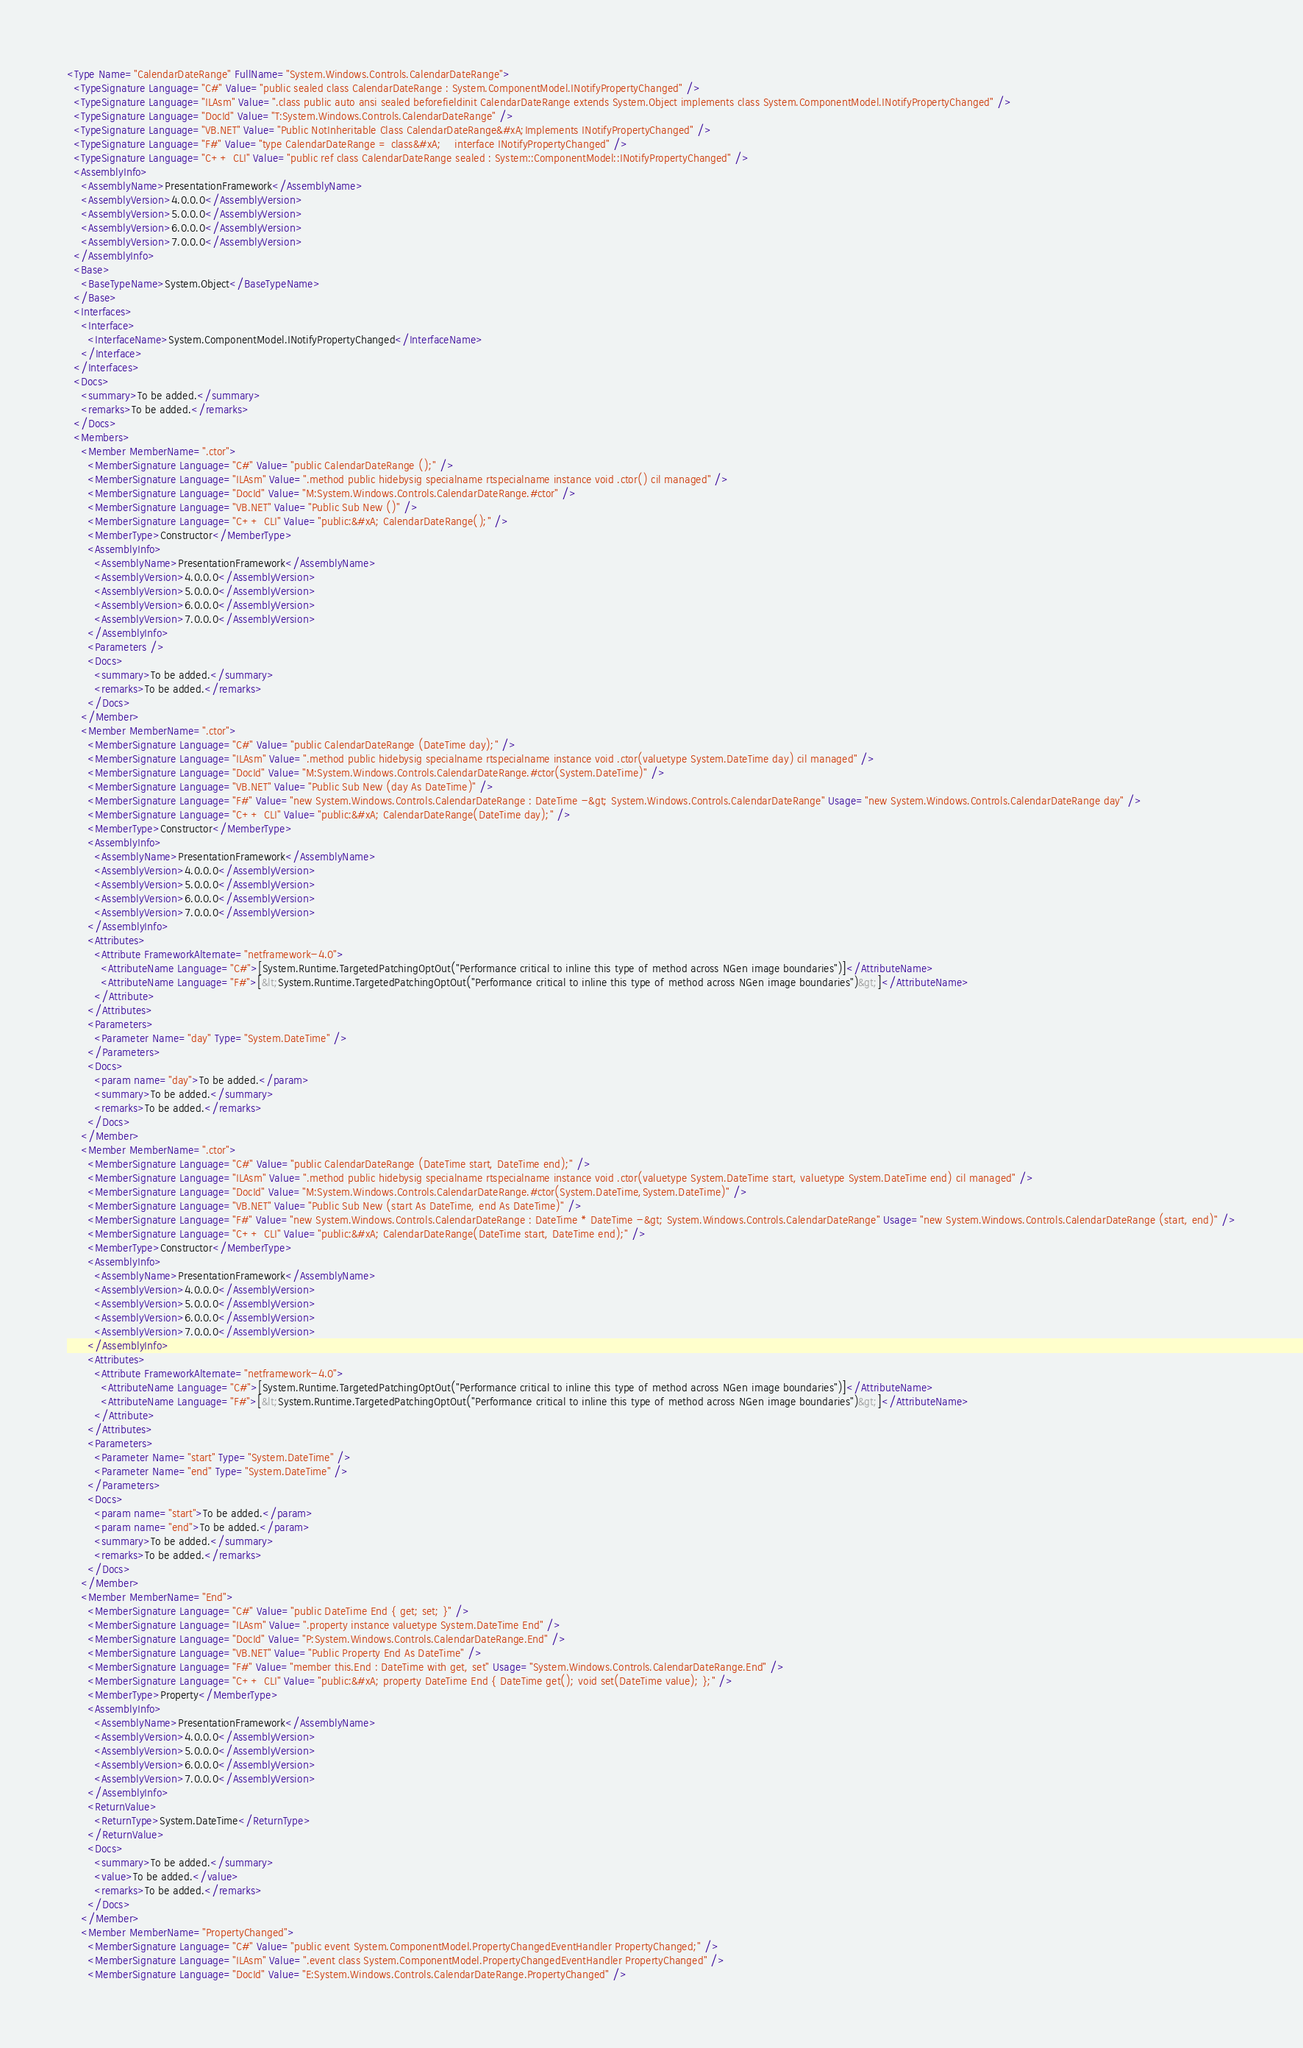Convert code to text. <code><loc_0><loc_0><loc_500><loc_500><_XML_><Type Name="CalendarDateRange" FullName="System.Windows.Controls.CalendarDateRange">
  <TypeSignature Language="C#" Value="public sealed class CalendarDateRange : System.ComponentModel.INotifyPropertyChanged" />
  <TypeSignature Language="ILAsm" Value=".class public auto ansi sealed beforefieldinit CalendarDateRange extends System.Object implements class System.ComponentModel.INotifyPropertyChanged" />
  <TypeSignature Language="DocId" Value="T:System.Windows.Controls.CalendarDateRange" />
  <TypeSignature Language="VB.NET" Value="Public NotInheritable Class CalendarDateRange&#xA;Implements INotifyPropertyChanged" />
  <TypeSignature Language="F#" Value="type CalendarDateRange = class&#xA;    interface INotifyPropertyChanged" />
  <TypeSignature Language="C++ CLI" Value="public ref class CalendarDateRange sealed : System::ComponentModel::INotifyPropertyChanged" />
  <AssemblyInfo>
    <AssemblyName>PresentationFramework</AssemblyName>
    <AssemblyVersion>4.0.0.0</AssemblyVersion>
    <AssemblyVersion>5.0.0.0</AssemblyVersion>
    <AssemblyVersion>6.0.0.0</AssemblyVersion>
    <AssemblyVersion>7.0.0.0</AssemblyVersion>
  </AssemblyInfo>
  <Base>
    <BaseTypeName>System.Object</BaseTypeName>
  </Base>
  <Interfaces>
    <Interface>
      <InterfaceName>System.ComponentModel.INotifyPropertyChanged</InterfaceName>
    </Interface>
  </Interfaces>
  <Docs>
    <summary>To be added.</summary>
    <remarks>To be added.</remarks>
  </Docs>
  <Members>
    <Member MemberName=".ctor">
      <MemberSignature Language="C#" Value="public CalendarDateRange ();" />
      <MemberSignature Language="ILAsm" Value=".method public hidebysig specialname rtspecialname instance void .ctor() cil managed" />
      <MemberSignature Language="DocId" Value="M:System.Windows.Controls.CalendarDateRange.#ctor" />
      <MemberSignature Language="VB.NET" Value="Public Sub New ()" />
      <MemberSignature Language="C++ CLI" Value="public:&#xA; CalendarDateRange();" />
      <MemberType>Constructor</MemberType>
      <AssemblyInfo>
        <AssemblyName>PresentationFramework</AssemblyName>
        <AssemblyVersion>4.0.0.0</AssemblyVersion>
        <AssemblyVersion>5.0.0.0</AssemblyVersion>
        <AssemblyVersion>6.0.0.0</AssemblyVersion>
        <AssemblyVersion>7.0.0.0</AssemblyVersion>
      </AssemblyInfo>
      <Parameters />
      <Docs>
        <summary>To be added.</summary>
        <remarks>To be added.</remarks>
      </Docs>
    </Member>
    <Member MemberName=".ctor">
      <MemberSignature Language="C#" Value="public CalendarDateRange (DateTime day);" />
      <MemberSignature Language="ILAsm" Value=".method public hidebysig specialname rtspecialname instance void .ctor(valuetype System.DateTime day) cil managed" />
      <MemberSignature Language="DocId" Value="M:System.Windows.Controls.CalendarDateRange.#ctor(System.DateTime)" />
      <MemberSignature Language="VB.NET" Value="Public Sub New (day As DateTime)" />
      <MemberSignature Language="F#" Value="new System.Windows.Controls.CalendarDateRange : DateTime -&gt; System.Windows.Controls.CalendarDateRange" Usage="new System.Windows.Controls.CalendarDateRange day" />
      <MemberSignature Language="C++ CLI" Value="public:&#xA; CalendarDateRange(DateTime day);" />
      <MemberType>Constructor</MemberType>
      <AssemblyInfo>
        <AssemblyName>PresentationFramework</AssemblyName>
        <AssemblyVersion>4.0.0.0</AssemblyVersion>
        <AssemblyVersion>5.0.0.0</AssemblyVersion>
        <AssemblyVersion>6.0.0.0</AssemblyVersion>
        <AssemblyVersion>7.0.0.0</AssemblyVersion>
      </AssemblyInfo>
      <Attributes>
        <Attribute FrameworkAlternate="netframework-4.0">
          <AttributeName Language="C#">[System.Runtime.TargetedPatchingOptOut("Performance critical to inline this type of method across NGen image boundaries")]</AttributeName>
          <AttributeName Language="F#">[&lt;System.Runtime.TargetedPatchingOptOut("Performance critical to inline this type of method across NGen image boundaries")&gt;]</AttributeName>
        </Attribute>
      </Attributes>
      <Parameters>
        <Parameter Name="day" Type="System.DateTime" />
      </Parameters>
      <Docs>
        <param name="day">To be added.</param>
        <summary>To be added.</summary>
        <remarks>To be added.</remarks>
      </Docs>
    </Member>
    <Member MemberName=".ctor">
      <MemberSignature Language="C#" Value="public CalendarDateRange (DateTime start, DateTime end);" />
      <MemberSignature Language="ILAsm" Value=".method public hidebysig specialname rtspecialname instance void .ctor(valuetype System.DateTime start, valuetype System.DateTime end) cil managed" />
      <MemberSignature Language="DocId" Value="M:System.Windows.Controls.CalendarDateRange.#ctor(System.DateTime,System.DateTime)" />
      <MemberSignature Language="VB.NET" Value="Public Sub New (start As DateTime, end As DateTime)" />
      <MemberSignature Language="F#" Value="new System.Windows.Controls.CalendarDateRange : DateTime * DateTime -&gt; System.Windows.Controls.CalendarDateRange" Usage="new System.Windows.Controls.CalendarDateRange (start, end)" />
      <MemberSignature Language="C++ CLI" Value="public:&#xA; CalendarDateRange(DateTime start, DateTime end);" />
      <MemberType>Constructor</MemberType>
      <AssemblyInfo>
        <AssemblyName>PresentationFramework</AssemblyName>
        <AssemblyVersion>4.0.0.0</AssemblyVersion>
        <AssemblyVersion>5.0.0.0</AssemblyVersion>
        <AssemblyVersion>6.0.0.0</AssemblyVersion>
        <AssemblyVersion>7.0.0.0</AssemblyVersion>
      </AssemblyInfo>
      <Attributes>
        <Attribute FrameworkAlternate="netframework-4.0">
          <AttributeName Language="C#">[System.Runtime.TargetedPatchingOptOut("Performance critical to inline this type of method across NGen image boundaries")]</AttributeName>
          <AttributeName Language="F#">[&lt;System.Runtime.TargetedPatchingOptOut("Performance critical to inline this type of method across NGen image boundaries")&gt;]</AttributeName>
        </Attribute>
      </Attributes>
      <Parameters>
        <Parameter Name="start" Type="System.DateTime" />
        <Parameter Name="end" Type="System.DateTime" />
      </Parameters>
      <Docs>
        <param name="start">To be added.</param>
        <param name="end">To be added.</param>
        <summary>To be added.</summary>
        <remarks>To be added.</remarks>
      </Docs>
    </Member>
    <Member MemberName="End">
      <MemberSignature Language="C#" Value="public DateTime End { get; set; }" />
      <MemberSignature Language="ILAsm" Value=".property instance valuetype System.DateTime End" />
      <MemberSignature Language="DocId" Value="P:System.Windows.Controls.CalendarDateRange.End" />
      <MemberSignature Language="VB.NET" Value="Public Property End As DateTime" />
      <MemberSignature Language="F#" Value="member this.End : DateTime with get, set" Usage="System.Windows.Controls.CalendarDateRange.End" />
      <MemberSignature Language="C++ CLI" Value="public:&#xA; property DateTime End { DateTime get(); void set(DateTime value); };" />
      <MemberType>Property</MemberType>
      <AssemblyInfo>
        <AssemblyName>PresentationFramework</AssemblyName>
        <AssemblyVersion>4.0.0.0</AssemblyVersion>
        <AssemblyVersion>5.0.0.0</AssemblyVersion>
        <AssemblyVersion>6.0.0.0</AssemblyVersion>
        <AssemblyVersion>7.0.0.0</AssemblyVersion>
      </AssemblyInfo>
      <ReturnValue>
        <ReturnType>System.DateTime</ReturnType>
      </ReturnValue>
      <Docs>
        <summary>To be added.</summary>
        <value>To be added.</value>
        <remarks>To be added.</remarks>
      </Docs>
    </Member>
    <Member MemberName="PropertyChanged">
      <MemberSignature Language="C#" Value="public event System.ComponentModel.PropertyChangedEventHandler PropertyChanged;" />
      <MemberSignature Language="ILAsm" Value=".event class System.ComponentModel.PropertyChangedEventHandler PropertyChanged" />
      <MemberSignature Language="DocId" Value="E:System.Windows.Controls.CalendarDateRange.PropertyChanged" /></code> 